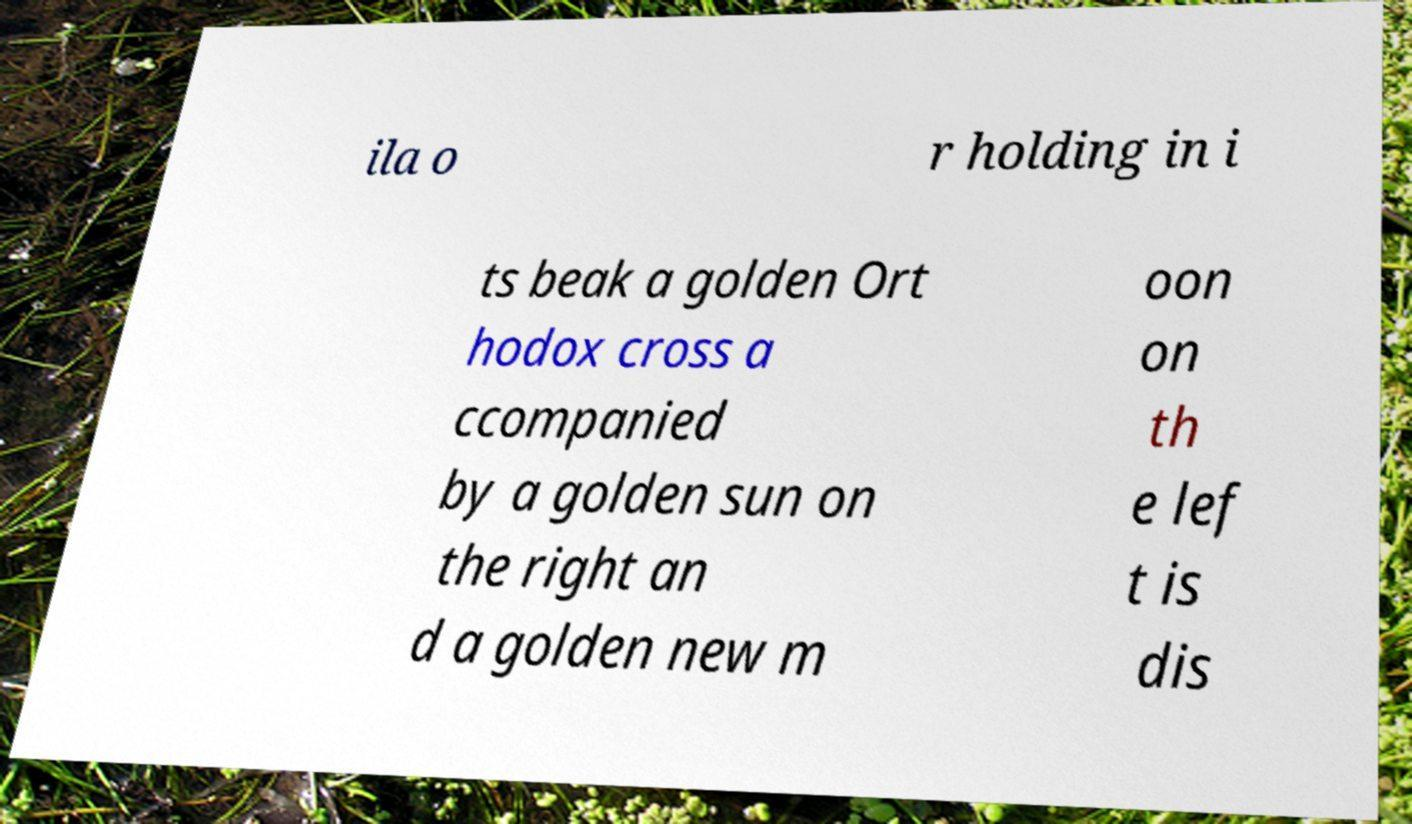Can you accurately transcribe the text from the provided image for me? ila o r holding in i ts beak a golden Ort hodox cross a ccompanied by a golden sun on the right an d a golden new m oon on th e lef t is dis 